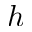<formula> <loc_0><loc_0><loc_500><loc_500>h</formula> 